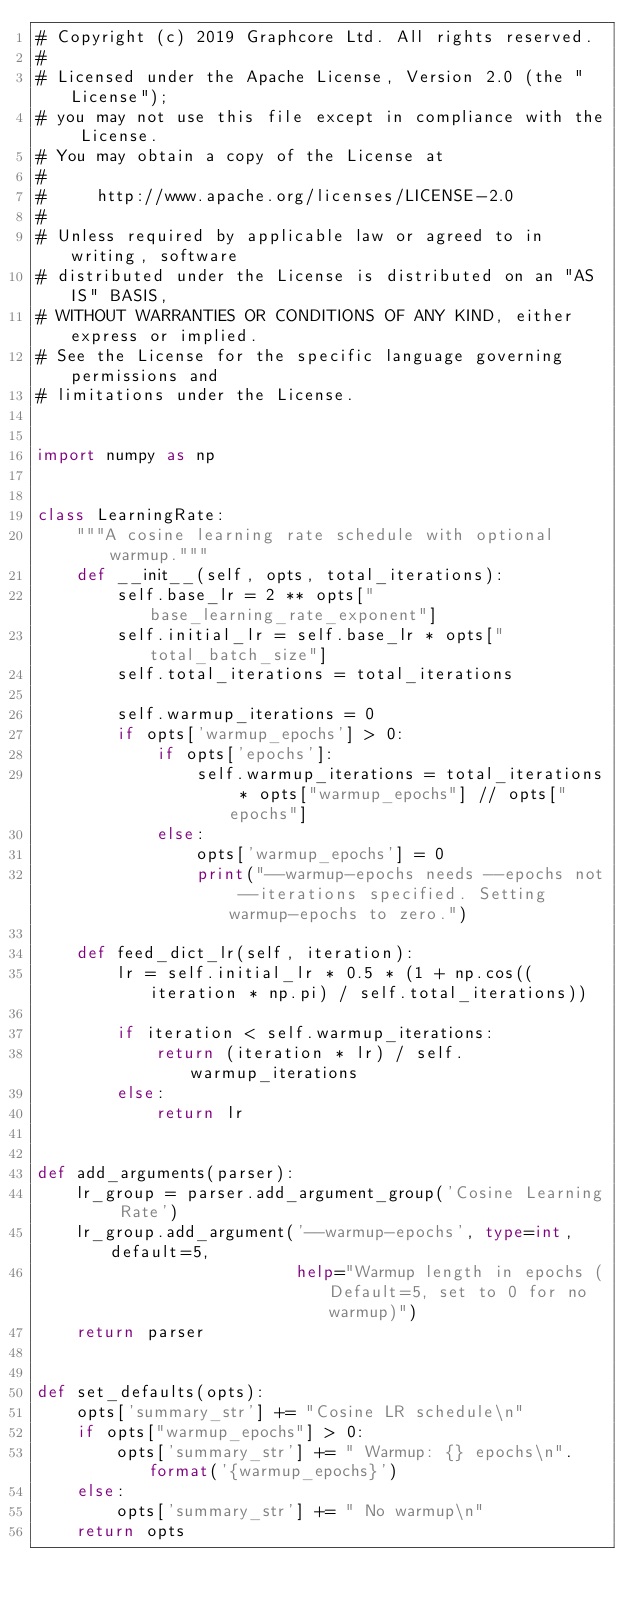Convert code to text. <code><loc_0><loc_0><loc_500><loc_500><_Python_># Copyright (c) 2019 Graphcore Ltd. All rights reserved.
#
# Licensed under the Apache License, Version 2.0 (the "License");
# you may not use this file except in compliance with the License.
# You may obtain a copy of the License at
#
#     http://www.apache.org/licenses/LICENSE-2.0
#
# Unless required by applicable law or agreed to in writing, software
# distributed under the License is distributed on an "AS IS" BASIS,
# WITHOUT WARRANTIES OR CONDITIONS OF ANY KIND, either express or implied.
# See the License for the specific language governing permissions and
# limitations under the License.


import numpy as np


class LearningRate:
    """A cosine learning rate schedule with optional warmup."""
    def __init__(self, opts, total_iterations):
        self.base_lr = 2 ** opts["base_learning_rate_exponent"]
        self.initial_lr = self.base_lr * opts["total_batch_size"]
        self.total_iterations = total_iterations

        self.warmup_iterations = 0
        if opts['warmup_epochs'] > 0:
            if opts['epochs']:
                self.warmup_iterations = total_iterations * opts["warmup_epochs"] // opts["epochs"]
            else:
                opts['warmup_epochs'] = 0
                print("--warmup-epochs needs --epochs not --iterations specified. Setting warmup-epochs to zero.")

    def feed_dict_lr(self, iteration):
        lr = self.initial_lr * 0.5 * (1 + np.cos((iteration * np.pi) / self.total_iterations))

        if iteration < self.warmup_iterations:
            return (iteration * lr) / self.warmup_iterations
        else:
            return lr


def add_arguments(parser):
    lr_group = parser.add_argument_group('Cosine Learning Rate')
    lr_group.add_argument('--warmup-epochs', type=int, default=5,
                          help="Warmup length in epochs (Default=5, set to 0 for no warmup)")
    return parser


def set_defaults(opts):
    opts['summary_str'] += "Cosine LR schedule\n"
    if opts["warmup_epochs"] > 0:
        opts['summary_str'] += " Warmup: {} epochs\n".format('{warmup_epochs}')
    else:
        opts['summary_str'] += " No warmup\n"
    return opts
</code> 